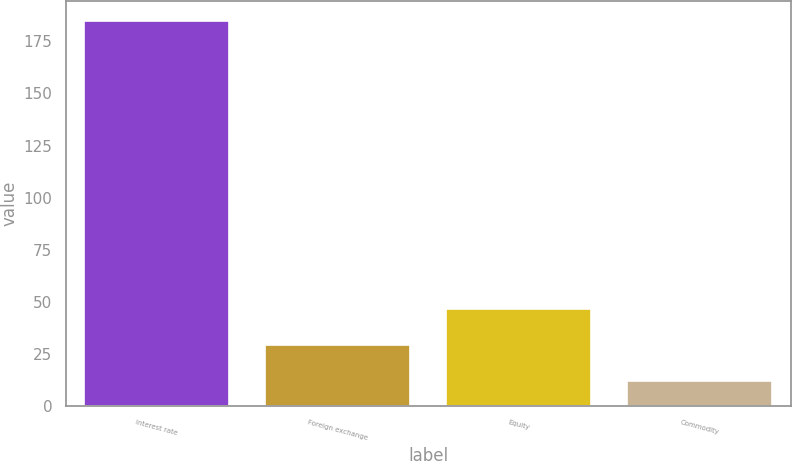<chart> <loc_0><loc_0><loc_500><loc_500><bar_chart><fcel>Interest rate<fcel>Foreign exchange<fcel>Equity<fcel>Commodity<nl><fcel>185<fcel>29.3<fcel>46.6<fcel>12<nl></chart> 